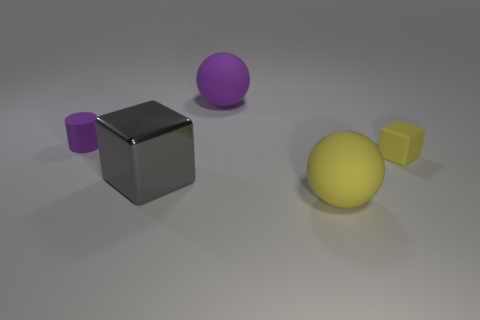Subtract all gray blocks. How many blocks are left? 1 Add 3 tiny brown metallic cylinders. How many objects exist? 8 Subtract 1 blocks. How many blocks are left? 1 Subtract all green cubes. Subtract all blue balls. How many cubes are left? 2 Subtract all cyan cylinders. How many yellow balls are left? 1 Subtract all yellow matte spheres. Subtract all large purple blocks. How many objects are left? 4 Add 2 tiny things. How many tiny things are left? 4 Add 4 small cylinders. How many small cylinders exist? 5 Subtract 0 brown cylinders. How many objects are left? 5 Subtract all blocks. How many objects are left? 3 